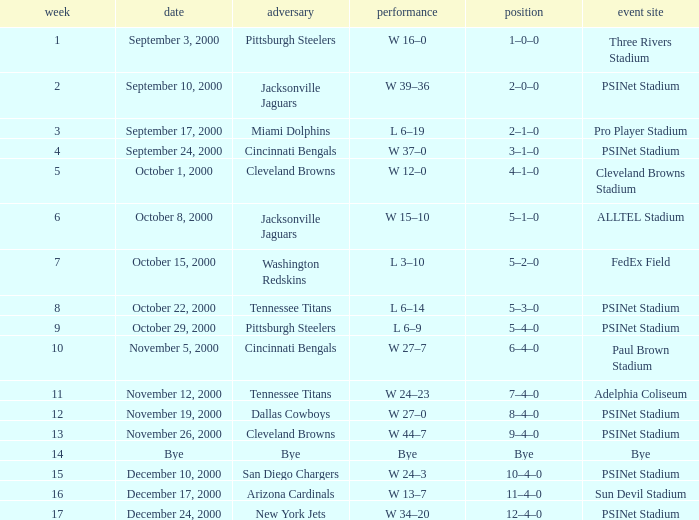What's the record for October 8, 2000 before week 13? 5–1–0. Would you be able to parse every entry in this table? {'header': ['week', 'date', 'adversary', 'performance', 'position', 'event site'], 'rows': [['1', 'September 3, 2000', 'Pittsburgh Steelers', 'W 16–0', '1–0–0', 'Three Rivers Stadium'], ['2', 'September 10, 2000', 'Jacksonville Jaguars', 'W 39–36', '2–0–0', 'PSINet Stadium'], ['3', 'September 17, 2000', 'Miami Dolphins', 'L 6–19', '2–1–0', 'Pro Player Stadium'], ['4', 'September 24, 2000', 'Cincinnati Bengals', 'W 37–0', '3–1–0', 'PSINet Stadium'], ['5', 'October 1, 2000', 'Cleveland Browns', 'W 12–0', '4–1–0', 'Cleveland Browns Stadium'], ['6', 'October 8, 2000', 'Jacksonville Jaguars', 'W 15–10', '5–1–0', 'ALLTEL Stadium'], ['7', 'October 15, 2000', 'Washington Redskins', 'L 3–10', '5–2–0', 'FedEx Field'], ['8', 'October 22, 2000', 'Tennessee Titans', 'L 6–14', '5–3–0', 'PSINet Stadium'], ['9', 'October 29, 2000', 'Pittsburgh Steelers', 'L 6–9', '5–4–0', 'PSINet Stadium'], ['10', 'November 5, 2000', 'Cincinnati Bengals', 'W 27–7', '6–4–0', 'Paul Brown Stadium'], ['11', 'November 12, 2000', 'Tennessee Titans', 'W 24–23', '7–4–0', 'Adelphia Coliseum'], ['12', 'November 19, 2000', 'Dallas Cowboys', 'W 27–0', '8–4–0', 'PSINet Stadium'], ['13', 'November 26, 2000', 'Cleveland Browns', 'W 44–7', '9–4–0', 'PSINet Stadium'], ['14', 'Bye', 'Bye', 'Bye', 'Bye', 'Bye'], ['15', 'December 10, 2000', 'San Diego Chargers', 'W 24–3', '10–4–0', 'PSINet Stadium'], ['16', 'December 17, 2000', 'Arizona Cardinals', 'W 13–7', '11–4–0', 'Sun Devil Stadium'], ['17', 'December 24, 2000', 'New York Jets', 'W 34–20', '12–4–0', 'PSINet Stadium']]} 